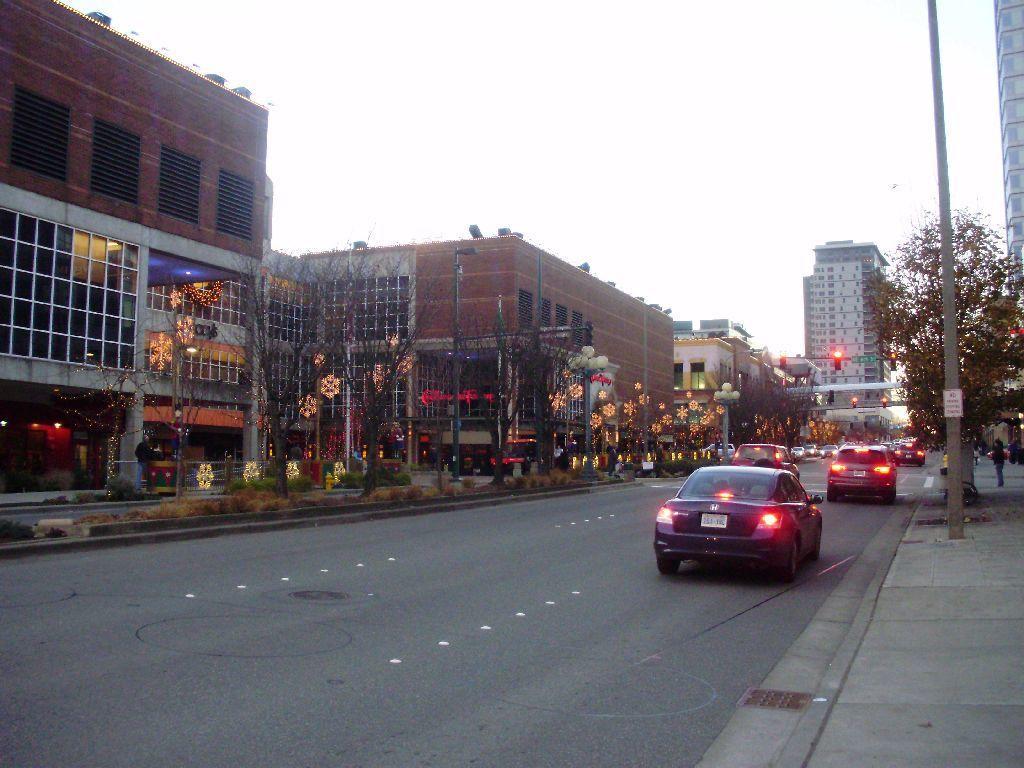Describe this image in one or two sentences. Here in this picture we can see number of cars present on the road and we can also see number of buildings and stores present over there and we can see plants and trees present and we can also see lights decoration near the buildings and we can see traffic signal lights present on a pole and we can see a person standing on the right side and we can also see a pole present. 